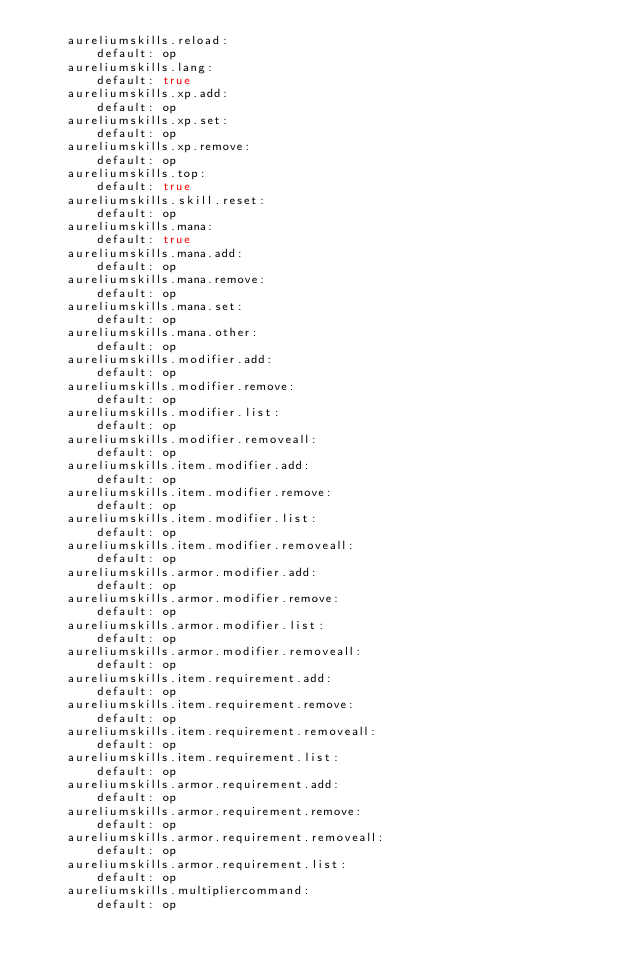Convert code to text. <code><loc_0><loc_0><loc_500><loc_500><_YAML_>    aureliumskills.reload:
        default: op
    aureliumskills.lang:
        default: true
    aureliumskills.xp.add:
        default: op
    aureliumskills.xp.set:
        default: op
    aureliumskills.xp.remove:
        default: op
    aureliumskills.top:
        default: true
    aureliumskills.skill.reset:
        default: op
    aureliumskills.mana:
        default: true
    aureliumskills.mana.add:
        default: op
    aureliumskills.mana.remove:
        default: op
    aureliumskills.mana.set:
        default: op
    aureliumskills.mana.other:
        default: op
    aureliumskills.modifier.add:
        default: op
    aureliumskills.modifier.remove:
        default: op
    aureliumskills.modifier.list:
        default: op
    aureliumskills.modifier.removeall:
        default: op
    aureliumskills.item.modifier.add:
        default: op
    aureliumskills.item.modifier.remove:
        default: op
    aureliumskills.item.modifier.list:
        default: op
    aureliumskills.item.modifier.removeall:
        default: op
    aureliumskills.armor.modifier.add:
        default: op
    aureliumskills.armor.modifier.remove:
        default: op
    aureliumskills.armor.modifier.list:
        default: op
    aureliumskills.armor.modifier.removeall:
        default: op
    aureliumskills.item.requirement.add:
        default: op
    aureliumskills.item.requirement.remove:
        default: op
    aureliumskills.item.requirement.removeall:
        default: op
    aureliumskills.item.requirement.list:
        default: op
    aureliumskills.armor.requirement.add:
        default: op
    aureliumskills.armor.requirement.remove:
        default: op
    aureliumskills.armor.requirement.removeall:
        default: op
    aureliumskills.armor.requirement.list:
        default: op
    aureliumskills.multipliercommand:
        default: op</code> 